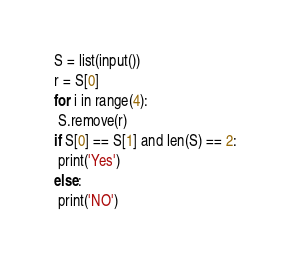Convert code to text. <code><loc_0><loc_0><loc_500><loc_500><_Python_>S = list(input())
r = S[0]
for i in range(4):
 S.remove(r)
if S[0] == S[1] and len(S) == 2:
 print('Yes')
else:
 print('NO')</code> 